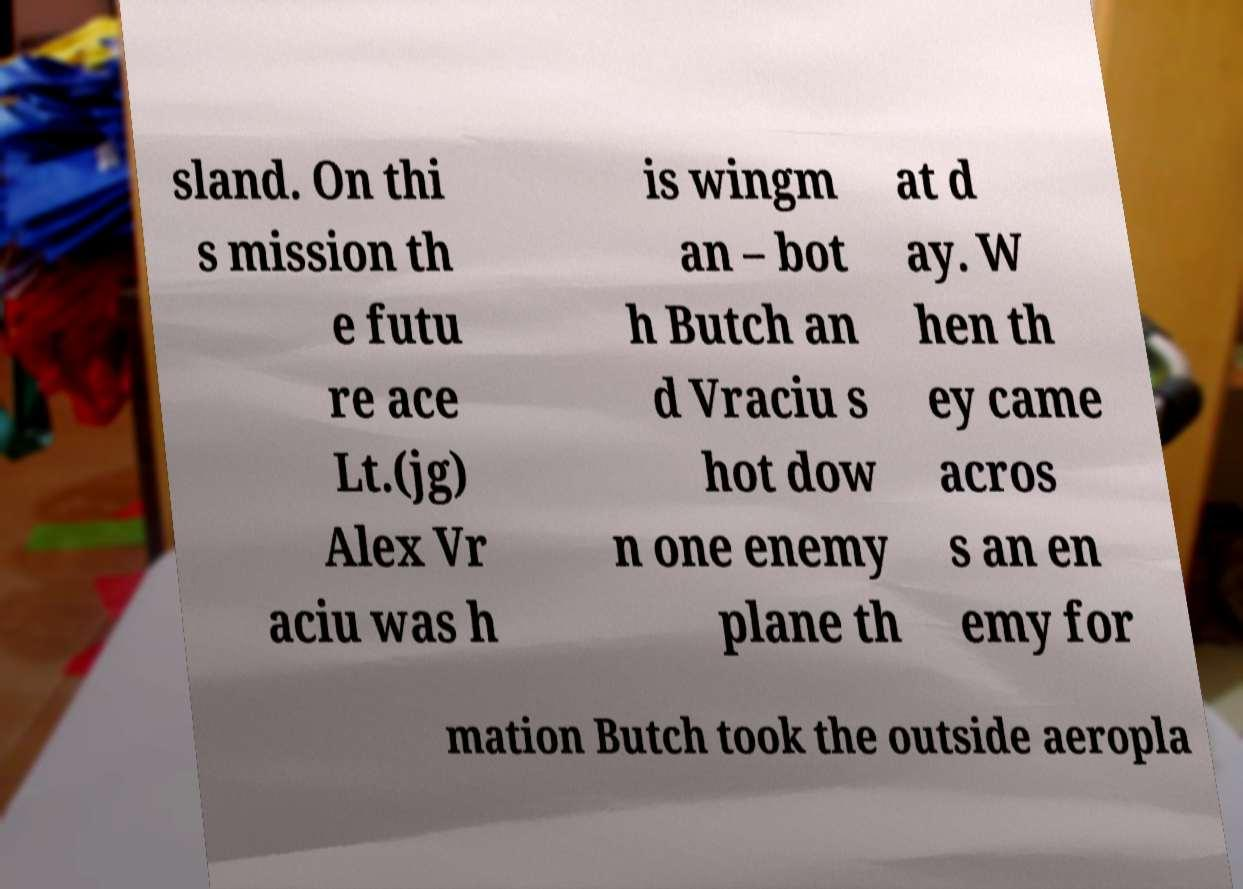For documentation purposes, I need the text within this image transcribed. Could you provide that? sland. On thi s mission th e futu re ace Lt.(jg) Alex Vr aciu was h is wingm an – bot h Butch an d Vraciu s hot dow n one enemy plane th at d ay. W hen th ey came acros s an en emy for mation Butch took the outside aeropla 